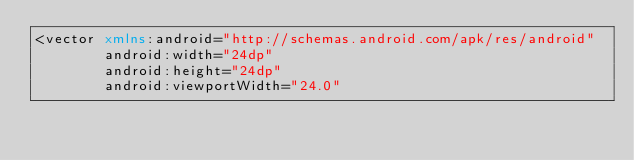<code> <loc_0><loc_0><loc_500><loc_500><_XML_><vector xmlns:android="http://schemas.android.com/apk/res/android"
        android:width="24dp"
        android:height="24dp"
        android:viewportWidth="24.0"</code> 